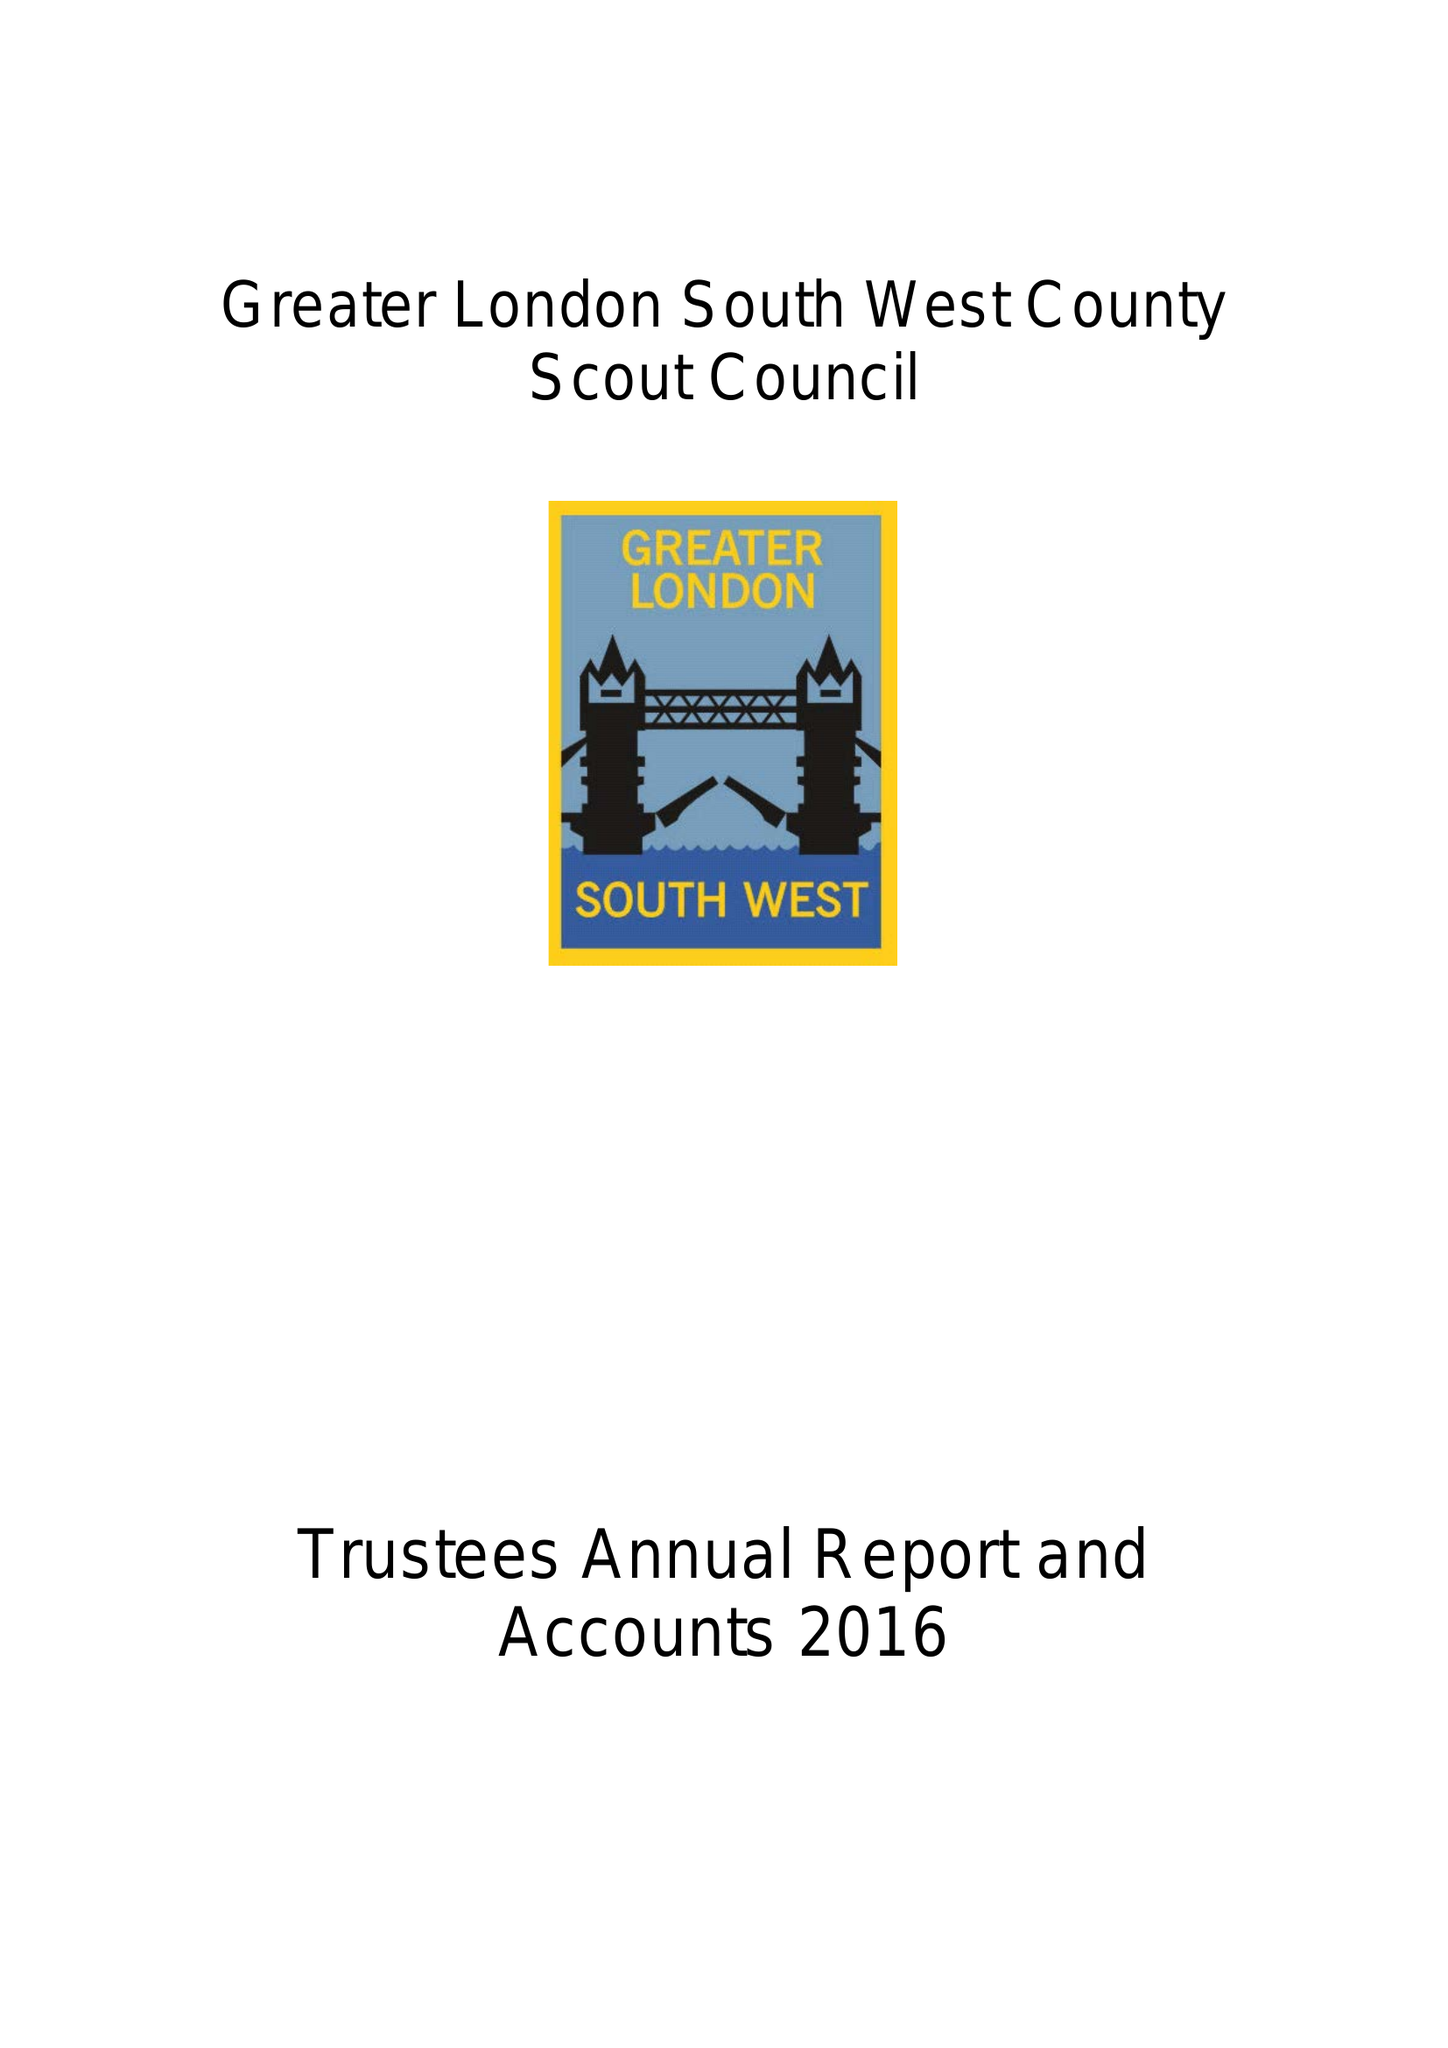What is the value for the address__postcode?
Answer the question using a single word or phrase. KT4 8UD 